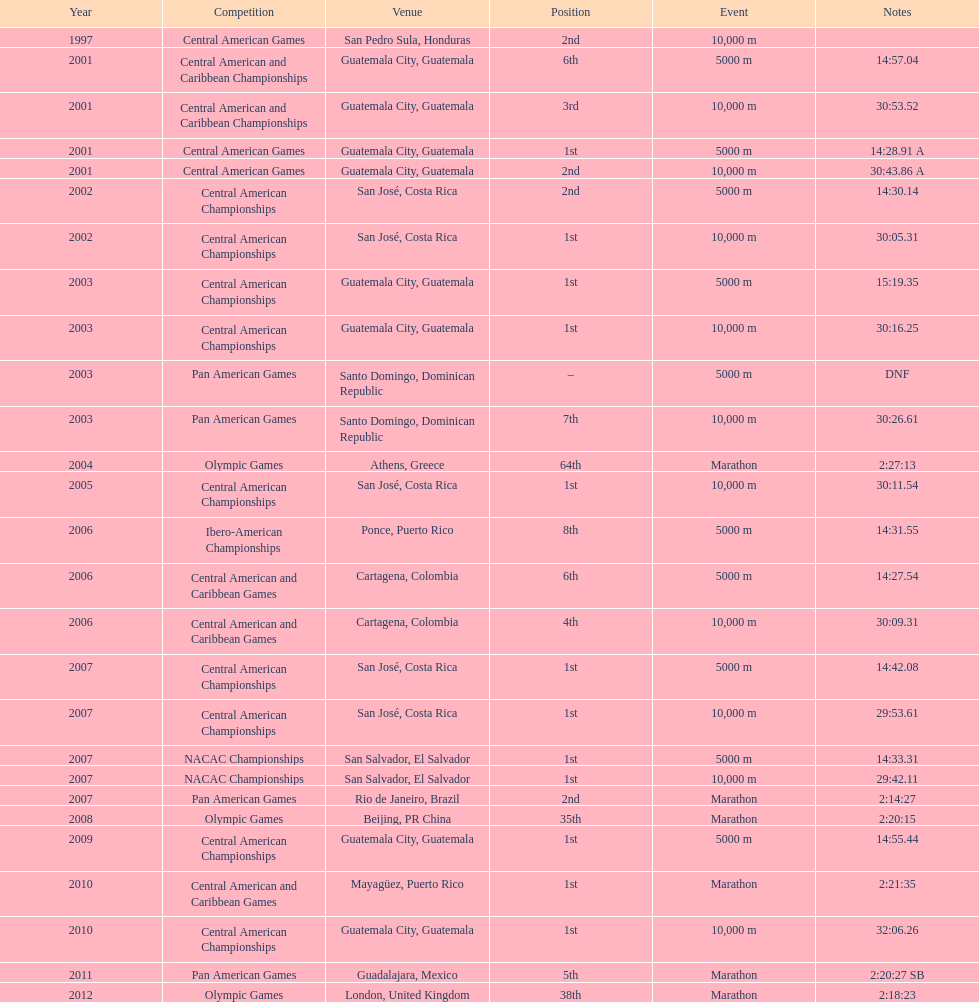Which event is listed more between the 10,000m and the 5000m? 10,000 m. 